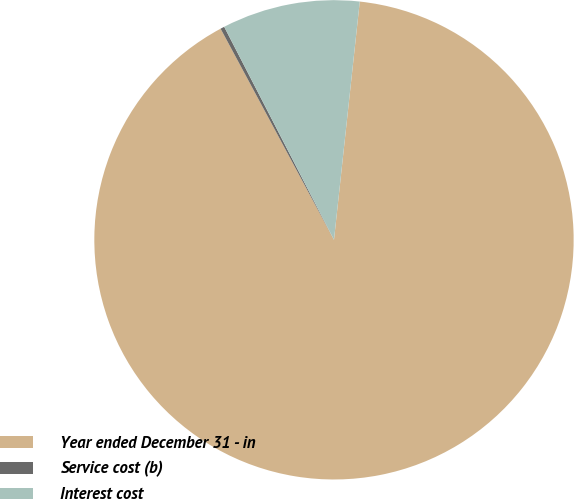Convert chart to OTSL. <chart><loc_0><loc_0><loc_500><loc_500><pie_chart><fcel>Year ended December 31 - in<fcel>Service cost (b)<fcel>Interest cost<nl><fcel>90.44%<fcel>0.27%<fcel>9.29%<nl></chart> 